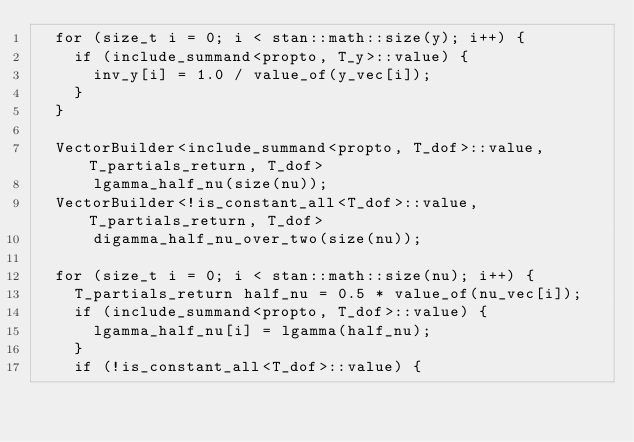<code> <loc_0><loc_0><loc_500><loc_500><_C++_>  for (size_t i = 0; i < stan::math::size(y); i++) {
    if (include_summand<propto, T_y>::value) {
      inv_y[i] = 1.0 / value_of(y_vec[i]);
    }
  }

  VectorBuilder<include_summand<propto, T_dof>::value, T_partials_return, T_dof>
      lgamma_half_nu(size(nu));
  VectorBuilder<!is_constant_all<T_dof>::value, T_partials_return, T_dof>
      digamma_half_nu_over_two(size(nu));

  for (size_t i = 0; i < stan::math::size(nu); i++) {
    T_partials_return half_nu = 0.5 * value_of(nu_vec[i]);
    if (include_summand<propto, T_dof>::value) {
      lgamma_half_nu[i] = lgamma(half_nu);
    }
    if (!is_constant_all<T_dof>::value) {</code> 